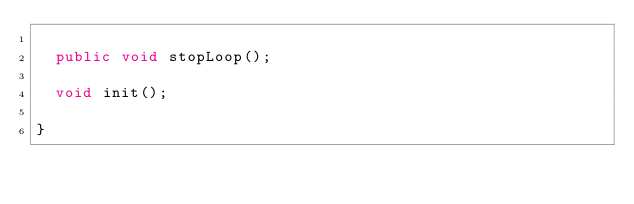<code> <loc_0><loc_0><loc_500><loc_500><_Java_>
  public void stopLoop();

  void init();

}
</code> 